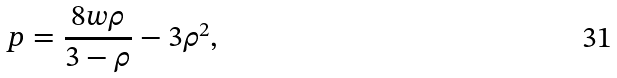<formula> <loc_0><loc_0><loc_500><loc_500>p = \frac { 8 w \rho } { 3 - \rho } - 3 \rho ^ { 2 } ,</formula> 